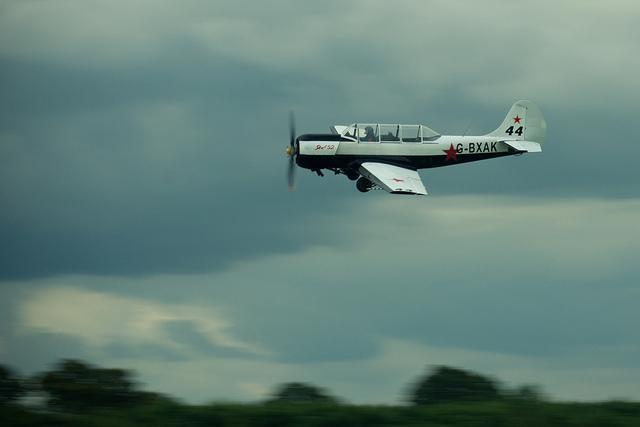How many toothbrushes are in the cup?
Give a very brief answer. 0. 